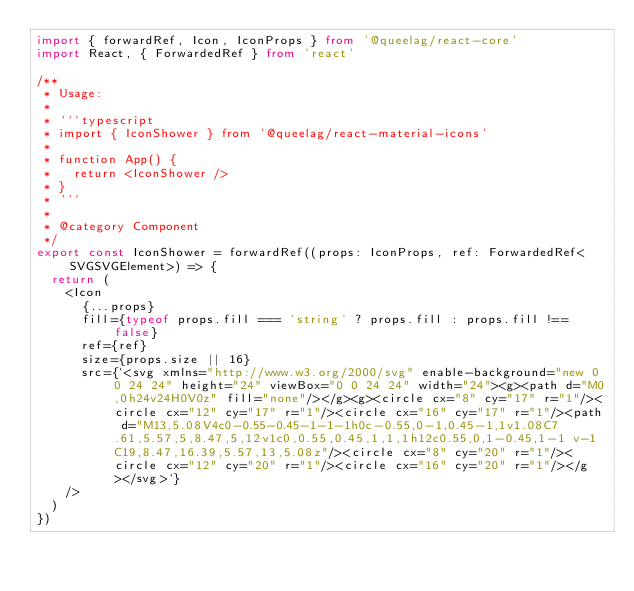<code> <loc_0><loc_0><loc_500><loc_500><_TypeScript_>import { forwardRef, Icon, IconProps } from '@queelag/react-core'
import React, { ForwardedRef } from 'react'

/**
 * Usage:
 *
 * ```typescript
 * import { IconShower } from '@queelag/react-material-icons'
 *
 * function App() {
 *   return <IconShower />
 * }
 * ```
 *
 * @category Component
 */
export const IconShower = forwardRef((props: IconProps, ref: ForwardedRef<SVGSVGElement>) => {
  return (
    <Icon
      {...props}
      fill={typeof props.fill === 'string' ? props.fill : props.fill !== false}
      ref={ref}
      size={props.size || 16}
      src={`<svg xmlns="http://www.w3.org/2000/svg" enable-background="new 0 0 24 24" height="24" viewBox="0 0 24 24" width="24"><g><path d="M0,0h24v24H0V0z" fill="none"/></g><g><circle cx="8" cy="17" r="1"/><circle cx="12" cy="17" r="1"/><circle cx="16" cy="17" r="1"/><path d="M13,5.08V4c0-0.55-0.45-1-1-1h0c-0.55,0-1,0.45-1,1v1.08C7.61,5.57,5,8.47,5,12v1c0,0.55,0.45,1,1,1h12c0.55,0,1-0.45,1-1 v-1C19,8.47,16.39,5.57,13,5.08z"/><circle cx="8" cy="20" r="1"/><circle cx="12" cy="20" r="1"/><circle cx="16" cy="20" r="1"/></g></svg>`}
    />
  )
})
</code> 